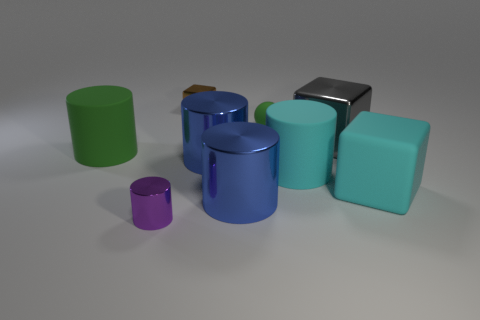Add 1 tiny brown metal blocks. How many objects exist? 10 Subtract all large green rubber cylinders. How many cylinders are left? 4 Subtract all purple cylinders. How many cylinders are left? 4 Subtract all cylinders. How many objects are left? 4 Subtract 1 spheres. How many spheres are left? 0 Subtract all red blocks. How many yellow spheres are left? 0 Add 4 blue metallic things. How many blue metallic things are left? 6 Add 6 big green metal cylinders. How many big green metal cylinders exist? 6 Subtract 0 gray balls. How many objects are left? 9 Subtract all red cylinders. Subtract all gray spheres. How many cylinders are left? 5 